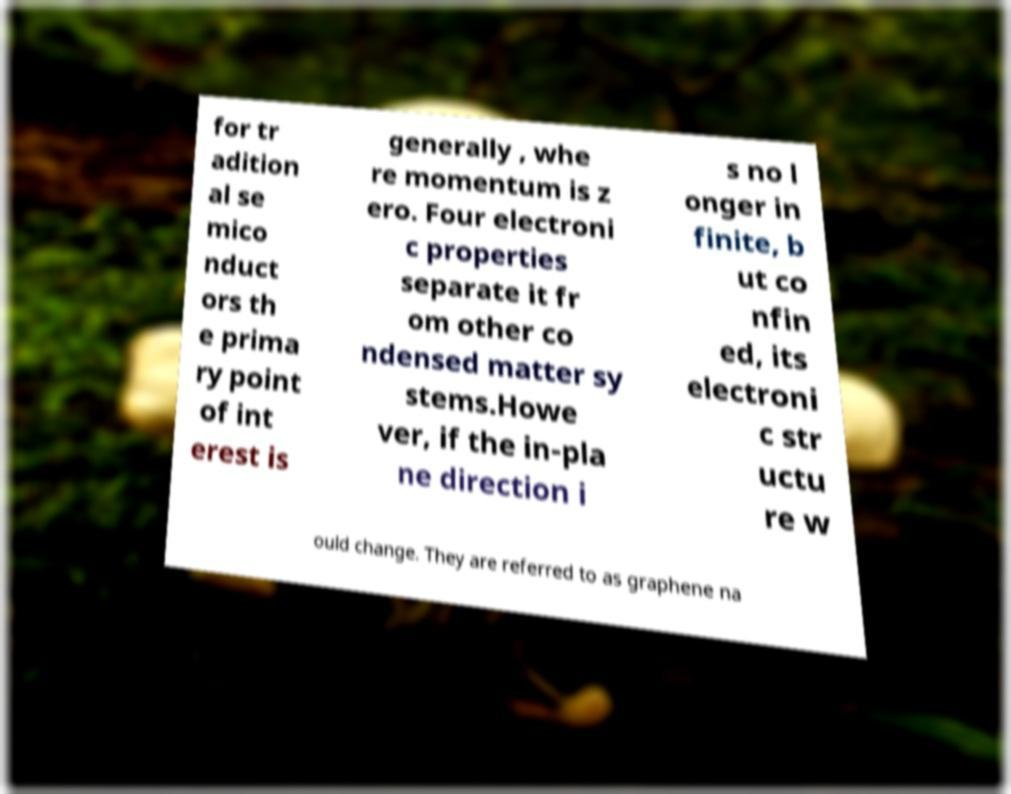Please read and relay the text visible in this image. What does it say? for tr adition al se mico nduct ors th e prima ry point of int erest is generally , whe re momentum is z ero. Four electroni c properties separate it fr om other co ndensed matter sy stems.Howe ver, if the in-pla ne direction i s no l onger in finite, b ut co nfin ed, its electroni c str uctu re w ould change. They are referred to as graphene na 